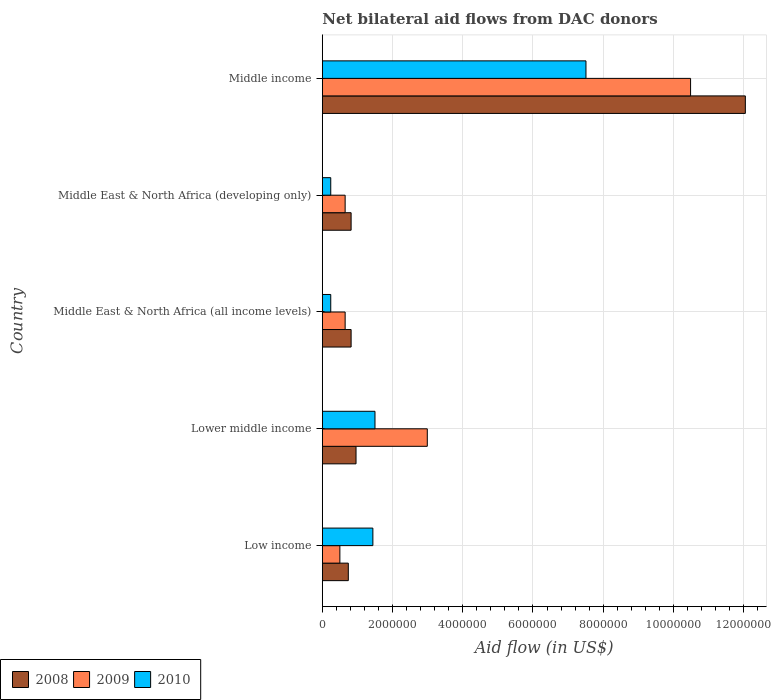How many bars are there on the 3rd tick from the bottom?
Give a very brief answer. 3. What is the label of the 2nd group of bars from the top?
Provide a succinct answer. Middle East & North Africa (developing only). In how many cases, is the number of bars for a given country not equal to the number of legend labels?
Provide a short and direct response. 0. What is the net bilateral aid flow in 2010 in Low income?
Your answer should be compact. 1.44e+06. Across all countries, what is the maximum net bilateral aid flow in 2008?
Offer a very short reply. 1.20e+07. In which country was the net bilateral aid flow in 2009 minimum?
Ensure brevity in your answer.  Low income. What is the total net bilateral aid flow in 2010 in the graph?
Offer a terse response. 1.09e+07. What is the difference between the net bilateral aid flow in 2008 in Middle East & North Africa (all income levels) and that in Middle income?
Ensure brevity in your answer.  -1.12e+07. What is the difference between the net bilateral aid flow in 2009 in Middle income and the net bilateral aid flow in 2008 in Lower middle income?
Give a very brief answer. 9.53e+06. What is the average net bilateral aid flow in 2010 per country?
Make the answer very short. 2.19e+06. What is the difference between the net bilateral aid flow in 2009 and net bilateral aid flow in 2010 in Middle East & North Africa (all income levels)?
Your answer should be compact. 4.10e+05. What is the ratio of the net bilateral aid flow in 2008 in Low income to that in Lower middle income?
Provide a succinct answer. 0.77. What is the difference between the highest and the second highest net bilateral aid flow in 2008?
Give a very brief answer. 1.11e+07. What is the difference between the highest and the lowest net bilateral aid flow in 2010?
Offer a terse response. 7.27e+06. Is the sum of the net bilateral aid flow in 2009 in Lower middle income and Middle East & North Africa (all income levels) greater than the maximum net bilateral aid flow in 2008 across all countries?
Give a very brief answer. No. Is it the case that in every country, the sum of the net bilateral aid flow in 2008 and net bilateral aid flow in 2010 is greater than the net bilateral aid flow in 2009?
Provide a short and direct response. No. How many bars are there?
Give a very brief answer. 15. Are all the bars in the graph horizontal?
Offer a very short reply. Yes. How many countries are there in the graph?
Keep it short and to the point. 5. What is the difference between two consecutive major ticks on the X-axis?
Ensure brevity in your answer.  2.00e+06. Are the values on the major ticks of X-axis written in scientific E-notation?
Give a very brief answer. No. How many legend labels are there?
Your response must be concise. 3. How are the legend labels stacked?
Your answer should be very brief. Horizontal. What is the title of the graph?
Your answer should be compact. Net bilateral aid flows from DAC donors. Does "1973" appear as one of the legend labels in the graph?
Give a very brief answer. No. What is the label or title of the X-axis?
Provide a succinct answer. Aid flow (in US$). What is the Aid flow (in US$) of 2008 in Low income?
Provide a succinct answer. 7.40e+05. What is the Aid flow (in US$) of 2009 in Low income?
Offer a very short reply. 5.00e+05. What is the Aid flow (in US$) of 2010 in Low income?
Ensure brevity in your answer.  1.44e+06. What is the Aid flow (in US$) of 2008 in Lower middle income?
Offer a terse response. 9.60e+05. What is the Aid flow (in US$) of 2009 in Lower middle income?
Provide a succinct answer. 2.99e+06. What is the Aid flow (in US$) in 2010 in Lower middle income?
Offer a terse response. 1.50e+06. What is the Aid flow (in US$) in 2008 in Middle East & North Africa (all income levels)?
Ensure brevity in your answer.  8.20e+05. What is the Aid flow (in US$) in 2009 in Middle East & North Africa (all income levels)?
Make the answer very short. 6.50e+05. What is the Aid flow (in US$) of 2008 in Middle East & North Africa (developing only)?
Make the answer very short. 8.20e+05. What is the Aid flow (in US$) of 2009 in Middle East & North Africa (developing only)?
Your answer should be compact. 6.50e+05. What is the Aid flow (in US$) of 2008 in Middle income?
Offer a very short reply. 1.20e+07. What is the Aid flow (in US$) in 2009 in Middle income?
Make the answer very short. 1.05e+07. What is the Aid flow (in US$) of 2010 in Middle income?
Give a very brief answer. 7.51e+06. Across all countries, what is the maximum Aid flow (in US$) in 2008?
Give a very brief answer. 1.20e+07. Across all countries, what is the maximum Aid flow (in US$) of 2009?
Your response must be concise. 1.05e+07. Across all countries, what is the maximum Aid flow (in US$) of 2010?
Keep it short and to the point. 7.51e+06. Across all countries, what is the minimum Aid flow (in US$) in 2008?
Your response must be concise. 7.40e+05. Across all countries, what is the minimum Aid flow (in US$) of 2009?
Your answer should be very brief. 5.00e+05. What is the total Aid flow (in US$) in 2008 in the graph?
Ensure brevity in your answer.  1.54e+07. What is the total Aid flow (in US$) in 2009 in the graph?
Your answer should be compact. 1.53e+07. What is the total Aid flow (in US$) of 2010 in the graph?
Provide a succinct answer. 1.09e+07. What is the difference between the Aid flow (in US$) in 2008 in Low income and that in Lower middle income?
Provide a short and direct response. -2.20e+05. What is the difference between the Aid flow (in US$) of 2009 in Low income and that in Lower middle income?
Offer a very short reply. -2.49e+06. What is the difference between the Aid flow (in US$) in 2010 in Low income and that in Lower middle income?
Give a very brief answer. -6.00e+04. What is the difference between the Aid flow (in US$) in 2009 in Low income and that in Middle East & North Africa (all income levels)?
Make the answer very short. -1.50e+05. What is the difference between the Aid flow (in US$) of 2010 in Low income and that in Middle East & North Africa (all income levels)?
Your answer should be very brief. 1.20e+06. What is the difference between the Aid flow (in US$) in 2010 in Low income and that in Middle East & North Africa (developing only)?
Offer a terse response. 1.20e+06. What is the difference between the Aid flow (in US$) of 2008 in Low income and that in Middle income?
Provide a succinct answer. -1.13e+07. What is the difference between the Aid flow (in US$) in 2009 in Low income and that in Middle income?
Provide a succinct answer. -9.99e+06. What is the difference between the Aid flow (in US$) of 2010 in Low income and that in Middle income?
Give a very brief answer. -6.07e+06. What is the difference between the Aid flow (in US$) in 2008 in Lower middle income and that in Middle East & North Africa (all income levels)?
Your answer should be very brief. 1.40e+05. What is the difference between the Aid flow (in US$) in 2009 in Lower middle income and that in Middle East & North Africa (all income levels)?
Your answer should be compact. 2.34e+06. What is the difference between the Aid flow (in US$) in 2010 in Lower middle income and that in Middle East & North Africa (all income levels)?
Your answer should be very brief. 1.26e+06. What is the difference between the Aid flow (in US$) of 2009 in Lower middle income and that in Middle East & North Africa (developing only)?
Keep it short and to the point. 2.34e+06. What is the difference between the Aid flow (in US$) of 2010 in Lower middle income and that in Middle East & North Africa (developing only)?
Provide a short and direct response. 1.26e+06. What is the difference between the Aid flow (in US$) in 2008 in Lower middle income and that in Middle income?
Provide a short and direct response. -1.11e+07. What is the difference between the Aid flow (in US$) in 2009 in Lower middle income and that in Middle income?
Your answer should be compact. -7.50e+06. What is the difference between the Aid flow (in US$) in 2010 in Lower middle income and that in Middle income?
Your answer should be compact. -6.01e+06. What is the difference between the Aid flow (in US$) of 2008 in Middle East & North Africa (all income levels) and that in Middle East & North Africa (developing only)?
Offer a terse response. 0. What is the difference between the Aid flow (in US$) in 2009 in Middle East & North Africa (all income levels) and that in Middle East & North Africa (developing only)?
Make the answer very short. 0. What is the difference between the Aid flow (in US$) in 2010 in Middle East & North Africa (all income levels) and that in Middle East & North Africa (developing only)?
Give a very brief answer. 0. What is the difference between the Aid flow (in US$) in 2008 in Middle East & North Africa (all income levels) and that in Middle income?
Provide a short and direct response. -1.12e+07. What is the difference between the Aid flow (in US$) in 2009 in Middle East & North Africa (all income levels) and that in Middle income?
Make the answer very short. -9.84e+06. What is the difference between the Aid flow (in US$) of 2010 in Middle East & North Africa (all income levels) and that in Middle income?
Offer a very short reply. -7.27e+06. What is the difference between the Aid flow (in US$) in 2008 in Middle East & North Africa (developing only) and that in Middle income?
Provide a short and direct response. -1.12e+07. What is the difference between the Aid flow (in US$) in 2009 in Middle East & North Africa (developing only) and that in Middle income?
Make the answer very short. -9.84e+06. What is the difference between the Aid flow (in US$) of 2010 in Middle East & North Africa (developing only) and that in Middle income?
Your answer should be very brief. -7.27e+06. What is the difference between the Aid flow (in US$) in 2008 in Low income and the Aid flow (in US$) in 2009 in Lower middle income?
Your response must be concise. -2.25e+06. What is the difference between the Aid flow (in US$) of 2008 in Low income and the Aid flow (in US$) of 2010 in Lower middle income?
Offer a terse response. -7.60e+05. What is the difference between the Aid flow (in US$) in 2009 in Low income and the Aid flow (in US$) in 2010 in Lower middle income?
Provide a short and direct response. -1.00e+06. What is the difference between the Aid flow (in US$) of 2008 in Low income and the Aid flow (in US$) of 2010 in Middle East & North Africa (all income levels)?
Offer a terse response. 5.00e+05. What is the difference between the Aid flow (in US$) in 2008 in Low income and the Aid flow (in US$) in 2010 in Middle East & North Africa (developing only)?
Offer a very short reply. 5.00e+05. What is the difference between the Aid flow (in US$) in 2008 in Low income and the Aid flow (in US$) in 2009 in Middle income?
Offer a terse response. -9.75e+06. What is the difference between the Aid flow (in US$) of 2008 in Low income and the Aid flow (in US$) of 2010 in Middle income?
Provide a succinct answer. -6.77e+06. What is the difference between the Aid flow (in US$) in 2009 in Low income and the Aid flow (in US$) in 2010 in Middle income?
Provide a short and direct response. -7.01e+06. What is the difference between the Aid flow (in US$) in 2008 in Lower middle income and the Aid flow (in US$) in 2009 in Middle East & North Africa (all income levels)?
Ensure brevity in your answer.  3.10e+05. What is the difference between the Aid flow (in US$) of 2008 in Lower middle income and the Aid flow (in US$) of 2010 in Middle East & North Africa (all income levels)?
Make the answer very short. 7.20e+05. What is the difference between the Aid flow (in US$) of 2009 in Lower middle income and the Aid flow (in US$) of 2010 in Middle East & North Africa (all income levels)?
Ensure brevity in your answer.  2.75e+06. What is the difference between the Aid flow (in US$) in 2008 in Lower middle income and the Aid flow (in US$) in 2010 in Middle East & North Africa (developing only)?
Offer a very short reply. 7.20e+05. What is the difference between the Aid flow (in US$) in 2009 in Lower middle income and the Aid flow (in US$) in 2010 in Middle East & North Africa (developing only)?
Offer a very short reply. 2.75e+06. What is the difference between the Aid flow (in US$) of 2008 in Lower middle income and the Aid flow (in US$) of 2009 in Middle income?
Your response must be concise. -9.53e+06. What is the difference between the Aid flow (in US$) in 2008 in Lower middle income and the Aid flow (in US$) in 2010 in Middle income?
Make the answer very short. -6.55e+06. What is the difference between the Aid flow (in US$) in 2009 in Lower middle income and the Aid flow (in US$) in 2010 in Middle income?
Provide a short and direct response. -4.52e+06. What is the difference between the Aid flow (in US$) of 2008 in Middle East & North Africa (all income levels) and the Aid flow (in US$) of 2009 in Middle East & North Africa (developing only)?
Your response must be concise. 1.70e+05. What is the difference between the Aid flow (in US$) in 2008 in Middle East & North Africa (all income levels) and the Aid flow (in US$) in 2010 in Middle East & North Africa (developing only)?
Offer a very short reply. 5.80e+05. What is the difference between the Aid flow (in US$) of 2009 in Middle East & North Africa (all income levels) and the Aid flow (in US$) of 2010 in Middle East & North Africa (developing only)?
Offer a very short reply. 4.10e+05. What is the difference between the Aid flow (in US$) of 2008 in Middle East & North Africa (all income levels) and the Aid flow (in US$) of 2009 in Middle income?
Your answer should be compact. -9.67e+06. What is the difference between the Aid flow (in US$) of 2008 in Middle East & North Africa (all income levels) and the Aid flow (in US$) of 2010 in Middle income?
Keep it short and to the point. -6.69e+06. What is the difference between the Aid flow (in US$) of 2009 in Middle East & North Africa (all income levels) and the Aid flow (in US$) of 2010 in Middle income?
Keep it short and to the point. -6.86e+06. What is the difference between the Aid flow (in US$) in 2008 in Middle East & North Africa (developing only) and the Aid flow (in US$) in 2009 in Middle income?
Offer a terse response. -9.67e+06. What is the difference between the Aid flow (in US$) of 2008 in Middle East & North Africa (developing only) and the Aid flow (in US$) of 2010 in Middle income?
Ensure brevity in your answer.  -6.69e+06. What is the difference between the Aid flow (in US$) in 2009 in Middle East & North Africa (developing only) and the Aid flow (in US$) in 2010 in Middle income?
Offer a terse response. -6.86e+06. What is the average Aid flow (in US$) of 2008 per country?
Offer a terse response. 3.08e+06. What is the average Aid flow (in US$) of 2009 per country?
Your response must be concise. 3.06e+06. What is the average Aid flow (in US$) in 2010 per country?
Ensure brevity in your answer.  2.19e+06. What is the difference between the Aid flow (in US$) of 2008 and Aid flow (in US$) of 2009 in Low income?
Offer a terse response. 2.40e+05. What is the difference between the Aid flow (in US$) in 2008 and Aid flow (in US$) in 2010 in Low income?
Keep it short and to the point. -7.00e+05. What is the difference between the Aid flow (in US$) of 2009 and Aid flow (in US$) of 2010 in Low income?
Provide a short and direct response. -9.40e+05. What is the difference between the Aid flow (in US$) of 2008 and Aid flow (in US$) of 2009 in Lower middle income?
Offer a very short reply. -2.03e+06. What is the difference between the Aid flow (in US$) in 2008 and Aid flow (in US$) in 2010 in Lower middle income?
Give a very brief answer. -5.40e+05. What is the difference between the Aid flow (in US$) of 2009 and Aid flow (in US$) of 2010 in Lower middle income?
Ensure brevity in your answer.  1.49e+06. What is the difference between the Aid flow (in US$) of 2008 and Aid flow (in US$) of 2009 in Middle East & North Africa (all income levels)?
Provide a succinct answer. 1.70e+05. What is the difference between the Aid flow (in US$) in 2008 and Aid flow (in US$) in 2010 in Middle East & North Africa (all income levels)?
Your answer should be compact. 5.80e+05. What is the difference between the Aid flow (in US$) of 2008 and Aid flow (in US$) of 2010 in Middle East & North Africa (developing only)?
Your answer should be very brief. 5.80e+05. What is the difference between the Aid flow (in US$) of 2009 and Aid flow (in US$) of 2010 in Middle East & North Africa (developing only)?
Ensure brevity in your answer.  4.10e+05. What is the difference between the Aid flow (in US$) in 2008 and Aid flow (in US$) in 2009 in Middle income?
Your response must be concise. 1.56e+06. What is the difference between the Aid flow (in US$) in 2008 and Aid flow (in US$) in 2010 in Middle income?
Keep it short and to the point. 4.54e+06. What is the difference between the Aid flow (in US$) in 2009 and Aid flow (in US$) in 2010 in Middle income?
Your answer should be compact. 2.98e+06. What is the ratio of the Aid flow (in US$) of 2008 in Low income to that in Lower middle income?
Keep it short and to the point. 0.77. What is the ratio of the Aid flow (in US$) in 2009 in Low income to that in Lower middle income?
Offer a very short reply. 0.17. What is the ratio of the Aid flow (in US$) in 2010 in Low income to that in Lower middle income?
Keep it short and to the point. 0.96. What is the ratio of the Aid flow (in US$) in 2008 in Low income to that in Middle East & North Africa (all income levels)?
Your response must be concise. 0.9. What is the ratio of the Aid flow (in US$) in 2009 in Low income to that in Middle East & North Africa (all income levels)?
Provide a short and direct response. 0.77. What is the ratio of the Aid flow (in US$) of 2008 in Low income to that in Middle East & North Africa (developing only)?
Your response must be concise. 0.9. What is the ratio of the Aid flow (in US$) in 2009 in Low income to that in Middle East & North Africa (developing only)?
Keep it short and to the point. 0.77. What is the ratio of the Aid flow (in US$) of 2010 in Low income to that in Middle East & North Africa (developing only)?
Your answer should be compact. 6. What is the ratio of the Aid flow (in US$) of 2008 in Low income to that in Middle income?
Offer a terse response. 0.06. What is the ratio of the Aid flow (in US$) in 2009 in Low income to that in Middle income?
Provide a short and direct response. 0.05. What is the ratio of the Aid flow (in US$) of 2010 in Low income to that in Middle income?
Give a very brief answer. 0.19. What is the ratio of the Aid flow (in US$) of 2008 in Lower middle income to that in Middle East & North Africa (all income levels)?
Keep it short and to the point. 1.17. What is the ratio of the Aid flow (in US$) in 2010 in Lower middle income to that in Middle East & North Africa (all income levels)?
Keep it short and to the point. 6.25. What is the ratio of the Aid flow (in US$) in 2008 in Lower middle income to that in Middle East & North Africa (developing only)?
Keep it short and to the point. 1.17. What is the ratio of the Aid flow (in US$) in 2010 in Lower middle income to that in Middle East & North Africa (developing only)?
Offer a very short reply. 6.25. What is the ratio of the Aid flow (in US$) of 2008 in Lower middle income to that in Middle income?
Give a very brief answer. 0.08. What is the ratio of the Aid flow (in US$) of 2009 in Lower middle income to that in Middle income?
Give a very brief answer. 0.28. What is the ratio of the Aid flow (in US$) of 2010 in Lower middle income to that in Middle income?
Your answer should be very brief. 0.2. What is the ratio of the Aid flow (in US$) in 2008 in Middle East & North Africa (all income levels) to that in Middle East & North Africa (developing only)?
Offer a terse response. 1. What is the ratio of the Aid flow (in US$) in 2009 in Middle East & North Africa (all income levels) to that in Middle East & North Africa (developing only)?
Give a very brief answer. 1. What is the ratio of the Aid flow (in US$) of 2010 in Middle East & North Africa (all income levels) to that in Middle East & North Africa (developing only)?
Offer a very short reply. 1. What is the ratio of the Aid flow (in US$) in 2008 in Middle East & North Africa (all income levels) to that in Middle income?
Provide a succinct answer. 0.07. What is the ratio of the Aid flow (in US$) of 2009 in Middle East & North Africa (all income levels) to that in Middle income?
Provide a short and direct response. 0.06. What is the ratio of the Aid flow (in US$) in 2010 in Middle East & North Africa (all income levels) to that in Middle income?
Ensure brevity in your answer.  0.03. What is the ratio of the Aid flow (in US$) in 2008 in Middle East & North Africa (developing only) to that in Middle income?
Your answer should be very brief. 0.07. What is the ratio of the Aid flow (in US$) of 2009 in Middle East & North Africa (developing only) to that in Middle income?
Your response must be concise. 0.06. What is the ratio of the Aid flow (in US$) of 2010 in Middle East & North Africa (developing only) to that in Middle income?
Make the answer very short. 0.03. What is the difference between the highest and the second highest Aid flow (in US$) in 2008?
Your answer should be compact. 1.11e+07. What is the difference between the highest and the second highest Aid flow (in US$) in 2009?
Your answer should be very brief. 7.50e+06. What is the difference between the highest and the second highest Aid flow (in US$) of 2010?
Offer a very short reply. 6.01e+06. What is the difference between the highest and the lowest Aid flow (in US$) in 2008?
Your answer should be very brief. 1.13e+07. What is the difference between the highest and the lowest Aid flow (in US$) of 2009?
Ensure brevity in your answer.  9.99e+06. What is the difference between the highest and the lowest Aid flow (in US$) in 2010?
Offer a very short reply. 7.27e+06. 